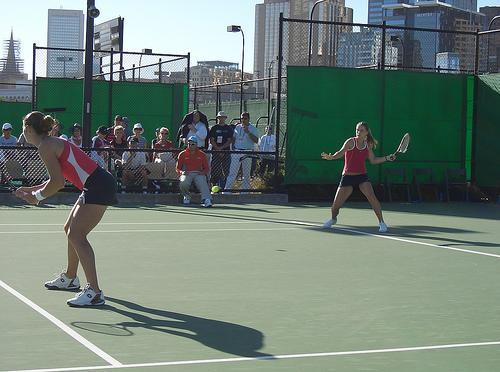Question: what color is the pitch?
Choices:
A. Yellow.
B. Brown.
C. Green.
D. Blue.
Answer with the letter. Answer: C Question: who is present?
Choices:
A. Horses.
B. People.
C. Cattle.
D. Orangutans.
Answer with the letter. Answer: B Question: where was this photo taken?
Choices:
A. Basketball court.
B. Hockey court.
C. On a tennis court.
D. Soccer field.
Answer with the letter. Answer: C 